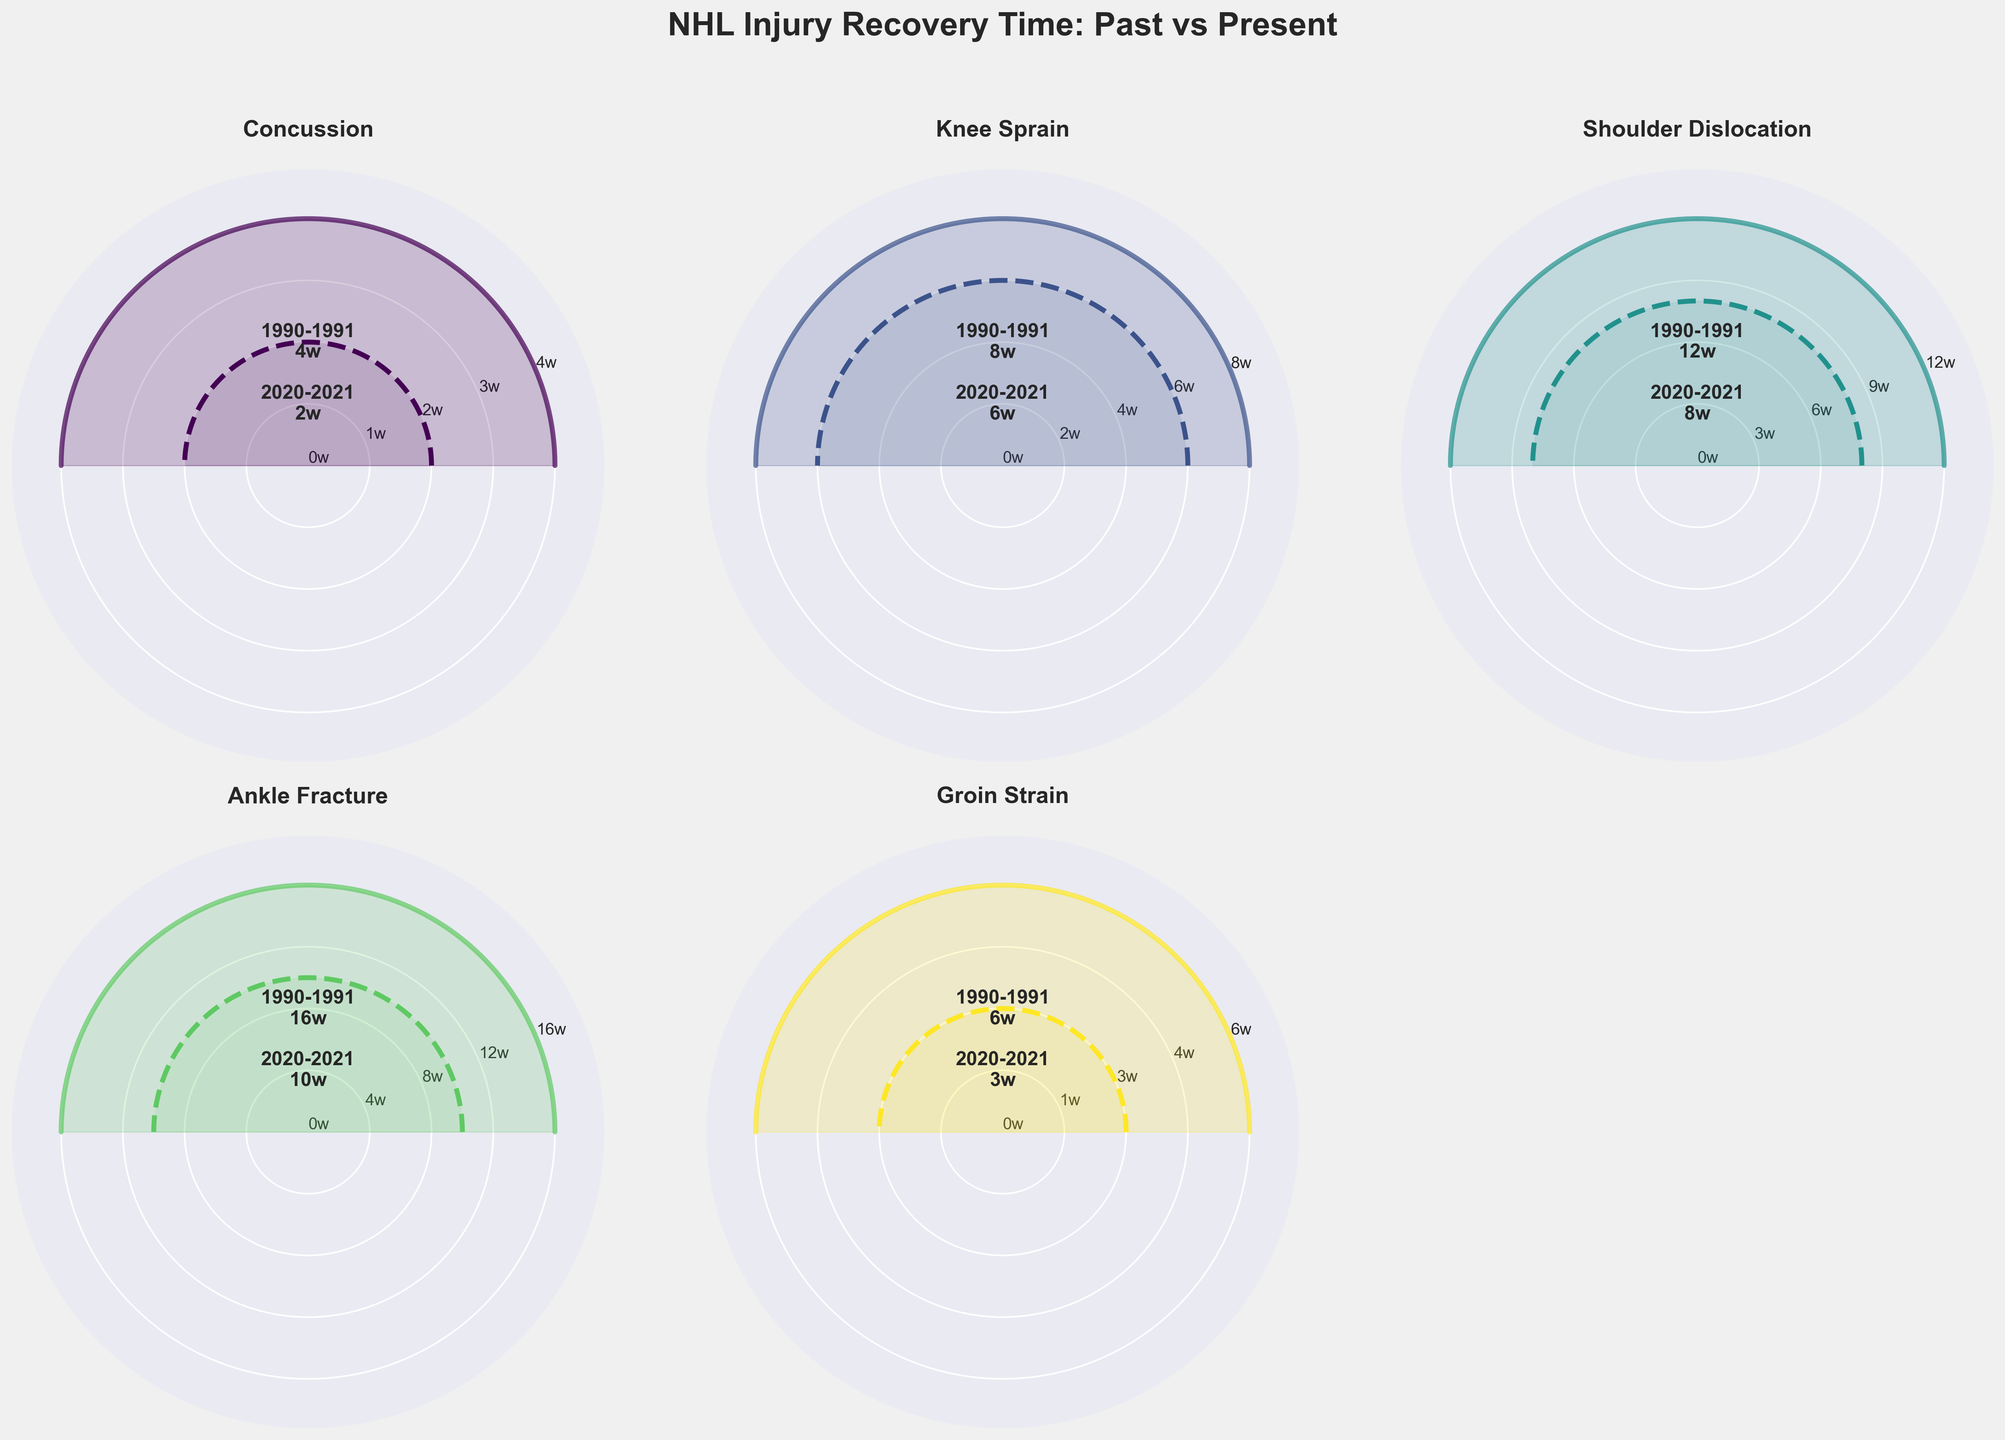Which season experienced shorter recovery times for shoulder dislocations? By comparing the figures representing shoulder dislocation recovery times, the 2020-2021 season has a displayed recovery time of 8 weeks, whereas the 1990-1991 season shows 12 weeks. Thus, the 2020-2021 season experienced shorter recovery times.
Answer: 2020-2021 What is the difference in average recovery time for ankle fractures between 1990-1991 and 2020-2021? The figure shows a recovery time of 16 weeks in 1990-1991 and 10 weeks in 2020-2021. The difference is calculated by subtracting 10 from 16.
Answer: 6 weeks Which injury type showed the greatest reduction in recovery time from 1990-1991 to 2020-2021? By comparing the reductions, concussion (4-2 weeks), knee sprain (8-6 weeks), shoulder dislocation (12-8 weeks), ankle fracture (16-10 weeks), and groin strain (6-3 weeks), ankle fracture shows the greatest reduction from 16 weeks to 10 weeks.
Answer: Ankle Fracture By how many weeks did the recovery time for groin strains improve from the 1990-1991 season to the 2020-2021 season? The figure shows groin strains recovery time decreased from 6 weeks in 1990-1991 to 3 weeks in 2020-2021. The improvement can be computed by subtracting 3 from 6.
Answer: 3 weeks Which season had a longer average recovery time for concussions? The figure indicates concussions required 4 weeks on average to recover in 1990-1991 but only 2 weeks in 2020-2021. Thus, the 1990-1991 season had a longer recovery time.
Answer: 1990-1991 How many more weeks were needed to recover from knee sprains in the 1990-1991 season compared to the 2020-2021 season? The knee sprain recovery time is shown as 8 weeks in 1990-1991 and 6 weeks in 2020-2021. Subtracting 6 from 8 gives the additional recovery time.
Answer: 2 weeks What's the average recovery time improvement across all injury types from 1990-1991 to 2020-2021? Summing the improvements: concussions from 4w to 2w (2 weeks), knee sprains from 8w to 6w (2 weeks), shoulder dislocations from 12w to 8w (4 weeks), ankle fractures from 16w to 10w (6 weeks), and groin strains from 6w to 3w (3 weeks) gives a total of 17 weeks improvement. Dividing this by the number of injury types (5) provides the average improvement.
Answer: 3.4 weeks Which injury type had the smallest change in recovery time between seasons? Reviewing each injury type: concussions improved by 2 weeks, knee sprains by 2 weeks, shoulder dislocations by 4 weeks, ankle fractures by 6 weeks, and groin strains by 3 weeks. Both concussions and knee sprains had the smallest change.
Answer: Concussion and Knee Sprain What does the greater width in the filled area between new and old recovery times indicate? The greater width reflects a larger discrepancy in average recovery times across the two seasons. For example, ankle fractures show a significant decrease from 16 weeks to 10 weeks, highlighting a broader gap.
Answer: Larger recovery time reduction Which injury type recovered most quickly in the 2020-2021 season? Scanning the 2020-2021 season recovery times: concussions (2 weeks), knee sprains (6 weeks), shoulder dislocations (8 weeks), ankle fractures (10 weeks), and groin strains (3 weeks). Concussions have the shortest recovery period of 2 weeks.
Answer: Concussion 